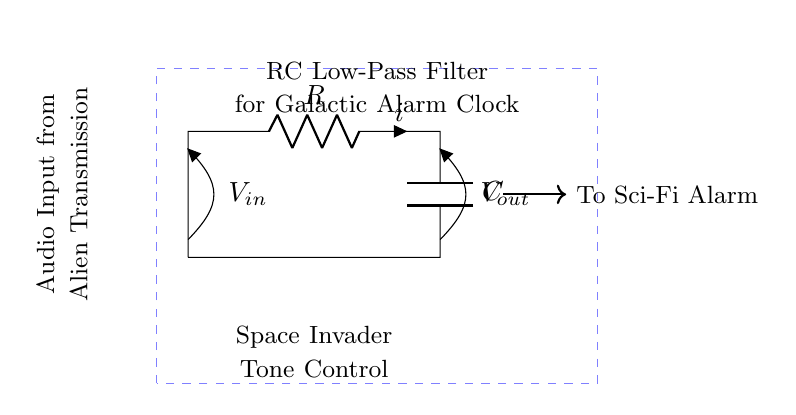What type of filter is represented in this circuit? The circuit diagram is labeled as an RC low-pass filter, which indicates that it allows low-frequency signals to pass while attenuating high-frequency signals.
Answer: RC low-pass filter What is connected to the output of the RC circuit? The output, labeled as V_out, is connected to the Sci-Fi Alarm, suggesting that it receives filtered audio signals from the RC low-pass filter.
Answer: Sci-Fi Alarm What is the purpose of the capacitor in this circuit? The capacitor in the RC low-pass filter circuit is responsible for blocking high-frequency signals, allowing low-frequency signals to reach the output more effectively, which is crucial for audio tone control.
Answer: Tone control What is the input of this circuit labeled as? The input of the circuit is labeled as V_in, indicating where the audio signal enters the RC low-pass filter circuit.
Answer: V_in What are the two components depicted in the circuit? The circuit diagram shows a resistor and a capacitor, which are the fundamental components of an RC filter used for audio applications.
Answer: Resistor and capacitor How does increasing the resistance affect the filter? Increasing resistance in an RC low-pass filter lowers the cutoff frequency, meaning that it allows even fewer high-frequency signals to pass through to the output, resulting in a smoother audio tone.
Answer: Lowers cutoff frequency 